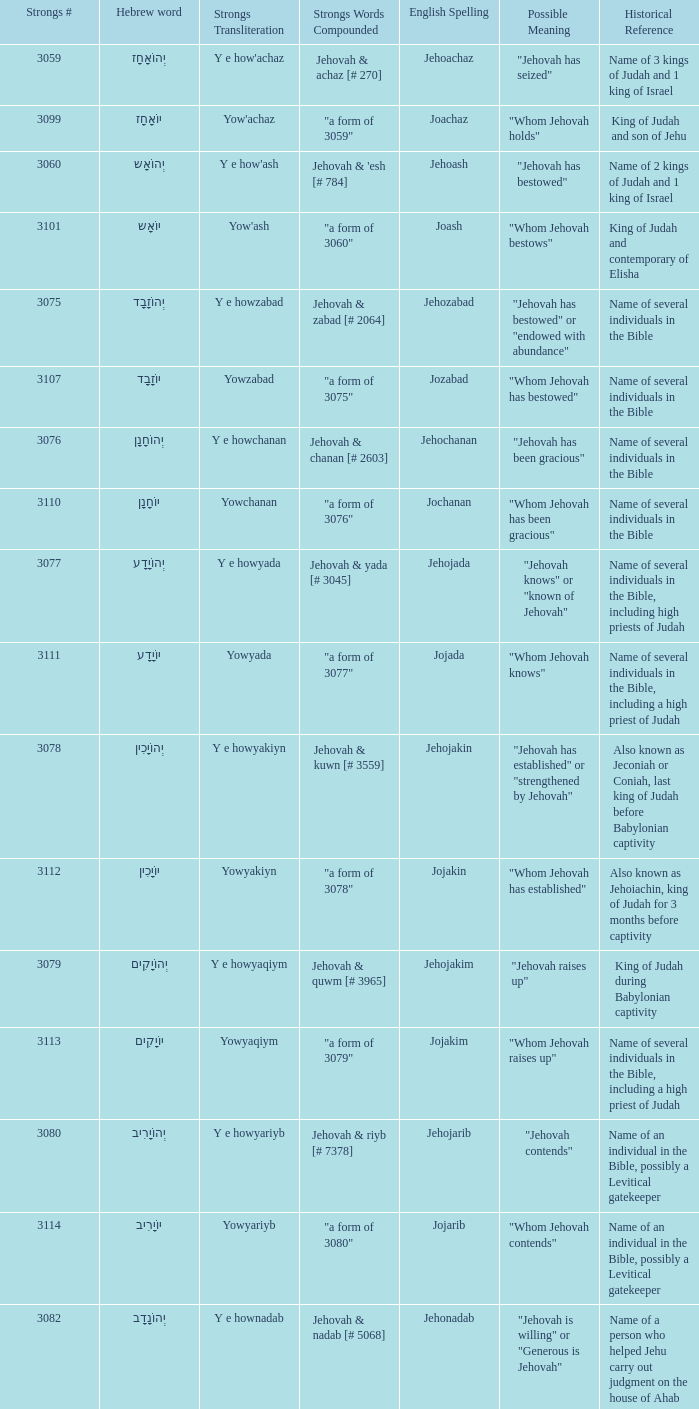What is the strongs words compounded when the english spelling is jonadab? "a form of 3082". 